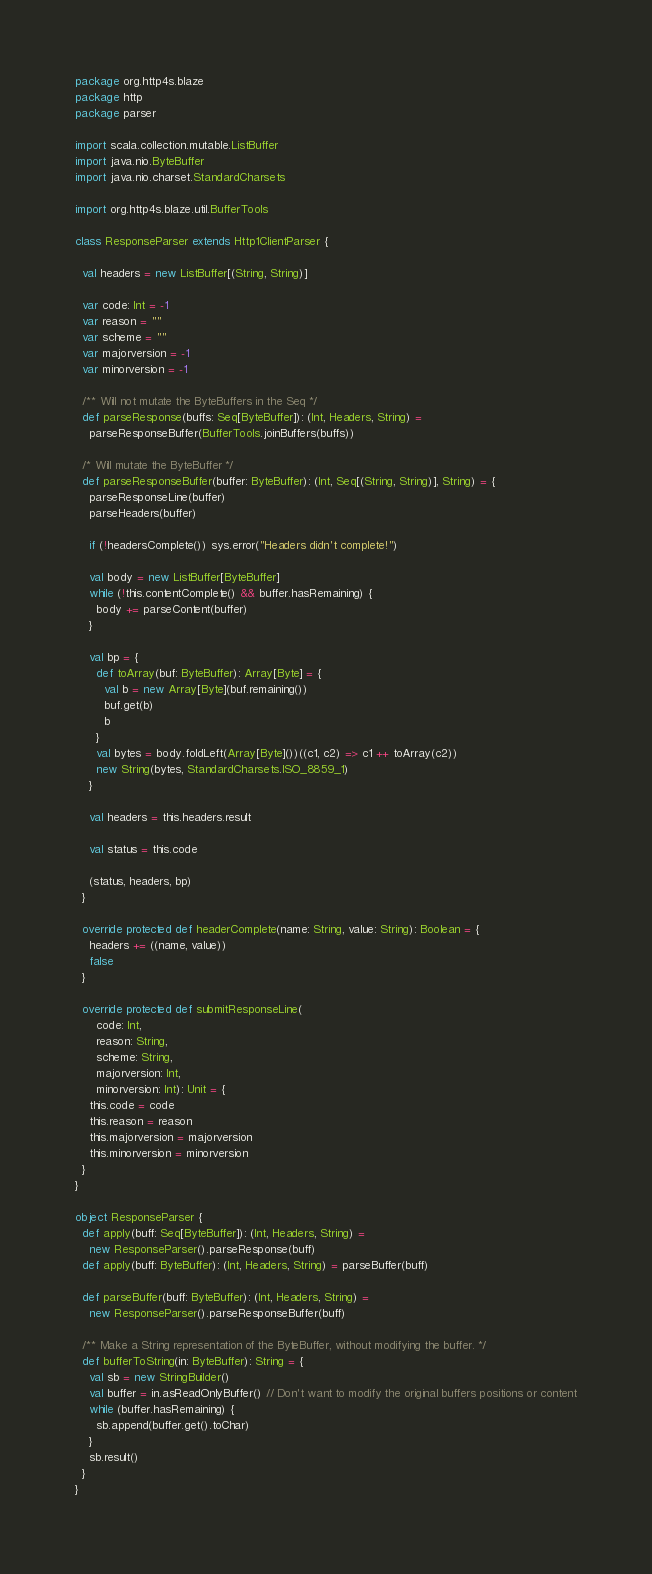<code> <loc_0><loc_0><loc_500><loc_500><_Scala_>package org.http4s.blaze
package http
package parser

import scala.collection.mutable.ListBuffer
import java.nio.ByteBuffer
import java.nio.charset.StandardCharsets

import org.http4s.blaze.util.BufferTools

class ResponseParser extends Http1ClientParser {

  val headers = new ListBuffer[(String, String)]

  var code: Int = -1
  var reason = ""
  var scheme = ""
  var majorversion = -1
  var minorversion = -1

  /** Will not mutate the ByteBuffers in the Seq */
  def parseResponse(buffs: Seq[ByteBuffer]): (Int, Headers, String) =
    parseResponseBuffer(BufferTools.joinBuffers(buffs))

  /* Will mutate the ByteBuffer */
  def parseResponseBuffer(buffer: ByteBuffer): (Int, Seq[(String, String)], String) = {
    parseResponseLine(buffer)
    parseHeaders(buffer)

    if (!headersComplete()) sys.error("Headers didn't complete!")

    val body = new ListBuffer[ByteBuffer]
    while (!this.contentComplete() && buffer.hasRemaining) {
      body += parseContent(buffer)
    }

    val bp = {
      def toArray(buf: ByteBuffer): Array[Byte] = {
        val b = new Array[Byte](buf.remaining())
        buf.get(b)
        b
      }
      val bytes = body.foldLeft(Array[Byte]())((c1, c2) => c1 ++ toArray(c2))
      new String(bytes, StandardCharsets.ISO_8859_1)
    }

    val headers = this.headers.result

    val status = this.code

    (status, headers, bp)
  }

  override protected def headerComplete(name: String, value: String): Boolean = {
    headers += ((name, value))
    false
  }

  override protected def submitResponseLine(
      code: Int,
      reason: String,
      scheme: String,
      majorversion: Int,
      minorversion: Int): Unit = {
    this.code = code
    this.reason = reason
    this.majorversion = majorversion
    this.minorversion = minorversion
  }
}

object ResponseParser {
  def apply(buff: Seq[ByteBuffer]): (Int, Headers, String) =
    new ResponseParser().parseResponse(buff)
  def apply(buff: ByteBuffer): (Int, Headers, String) = parseBuffer(buff)

  def parseBuffer(buff: ByteBuffer): (Int, Headers, String) =
    new ResponseParser().parseResponseBuffer(buff)

  /** Make a String representation of the ByteBuffer, without modifying the buffer. */
  def bufferToString(in: ByteBuffer): String = {
    val sb = new StringBuilder()
    val buffer = in.asReadOnlyBuffer() // Don't want to modify the original buffers positions or content
    while (buffer.hasRemaining) {
      sb.append(buffer.get().toChar)
    }
    sb.result()
  }
}
</code> 